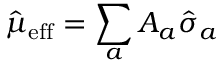<formula> <loc_0><loc_0><loc_500><loc_500>\hat { \mu } _ { e f f } = \sum _ { a } A _ { a } \hat { \sigma } _ { a }</formula> 